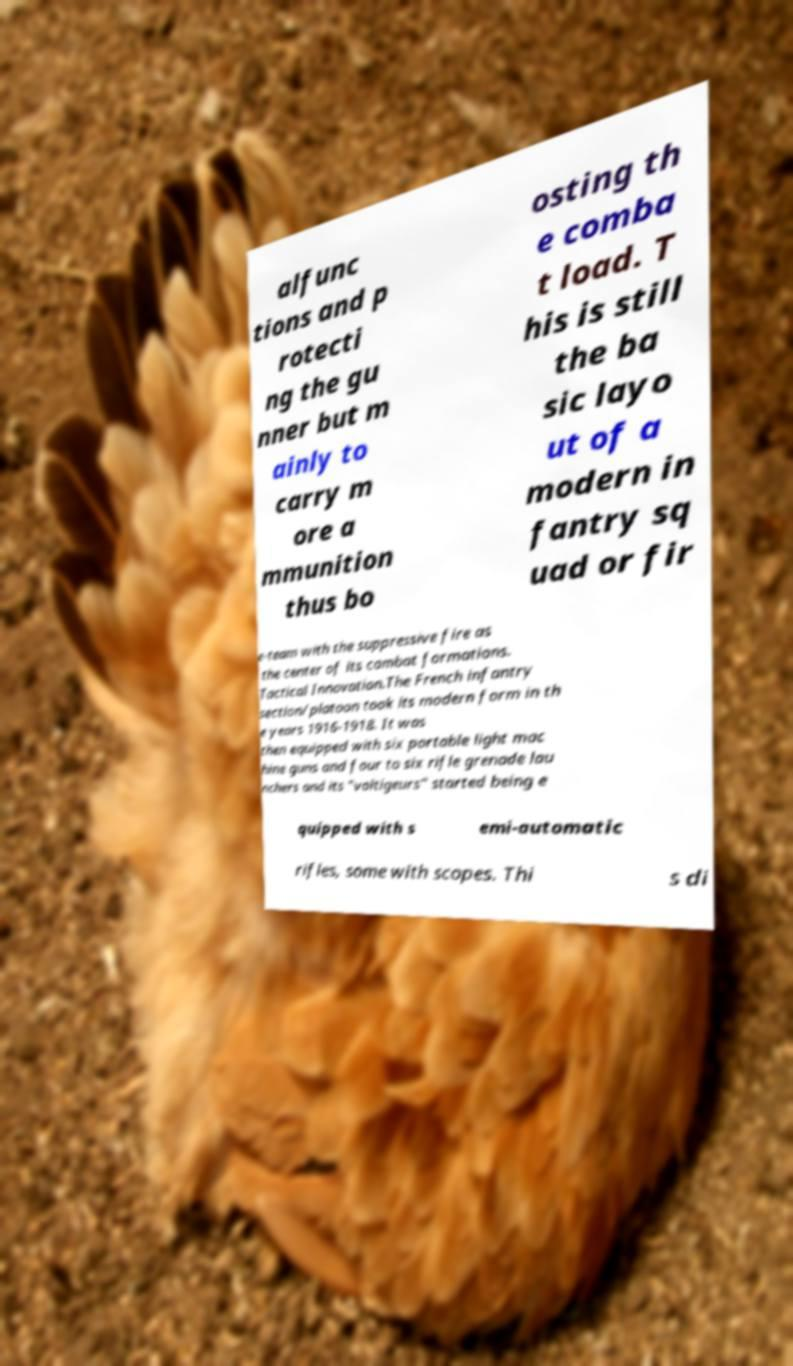Can you read and provide the text displayed in the image?This photo seems to have some interesting text. Can you extract and type it out for me? alfunc tions and p rotecti ng the gu nner but m ainly to carry m ore a mmunition thus bo osting th e comba t load. T his is still the ba sic layo ut of a modern in fantry sq uad or fir e-team with the suppressive fire as the center of its combat formations. Tactical Innovation.The French infantry section/platoon took its modern form in th e years 1916-1918. It was then equipped with six portable light mac hine guns and four to six rifle grenade lau nchers and its "voltigeurs" started being e quipped with s emi-automatic rifles, some with scopes. Thi s di 